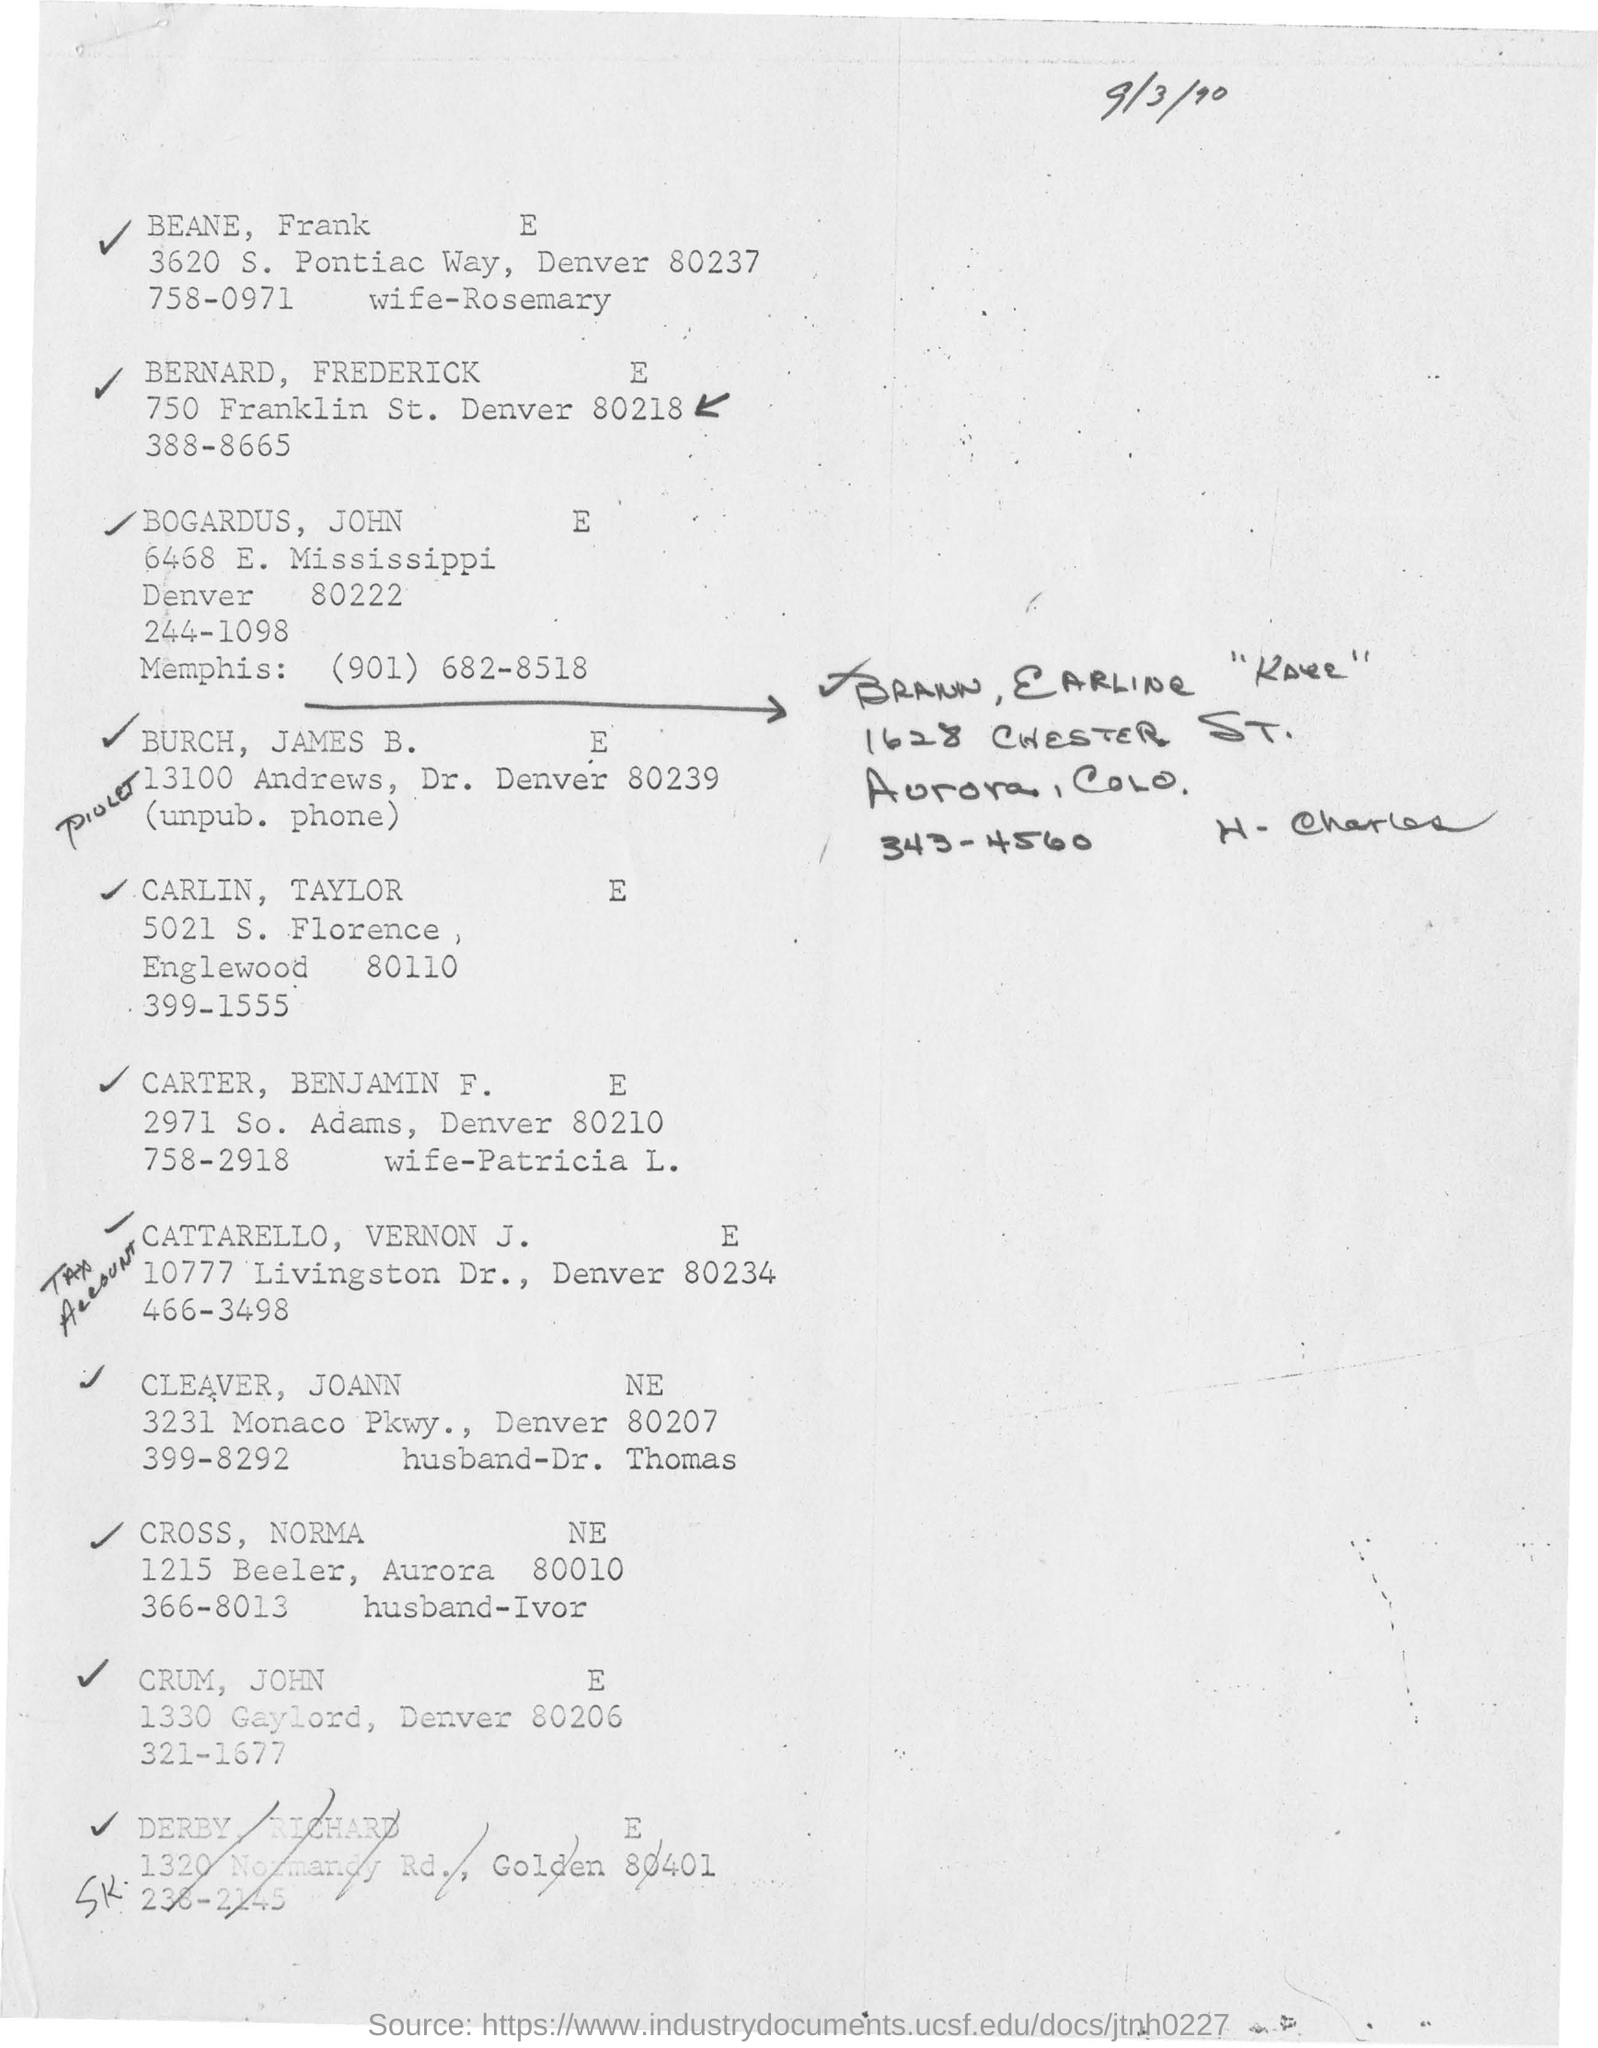Highlight a few significant elements in this photo. The document mentions a date of September 3, 1990. 